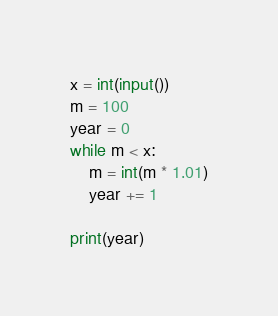<code> <loc_0><loc_0><loc_500><loc_500><_Python_>x = int(input())
m = 100
year = 0
while m < x:
    m = int(m * 1.01)
    year += 1
    
print(year)</code> 